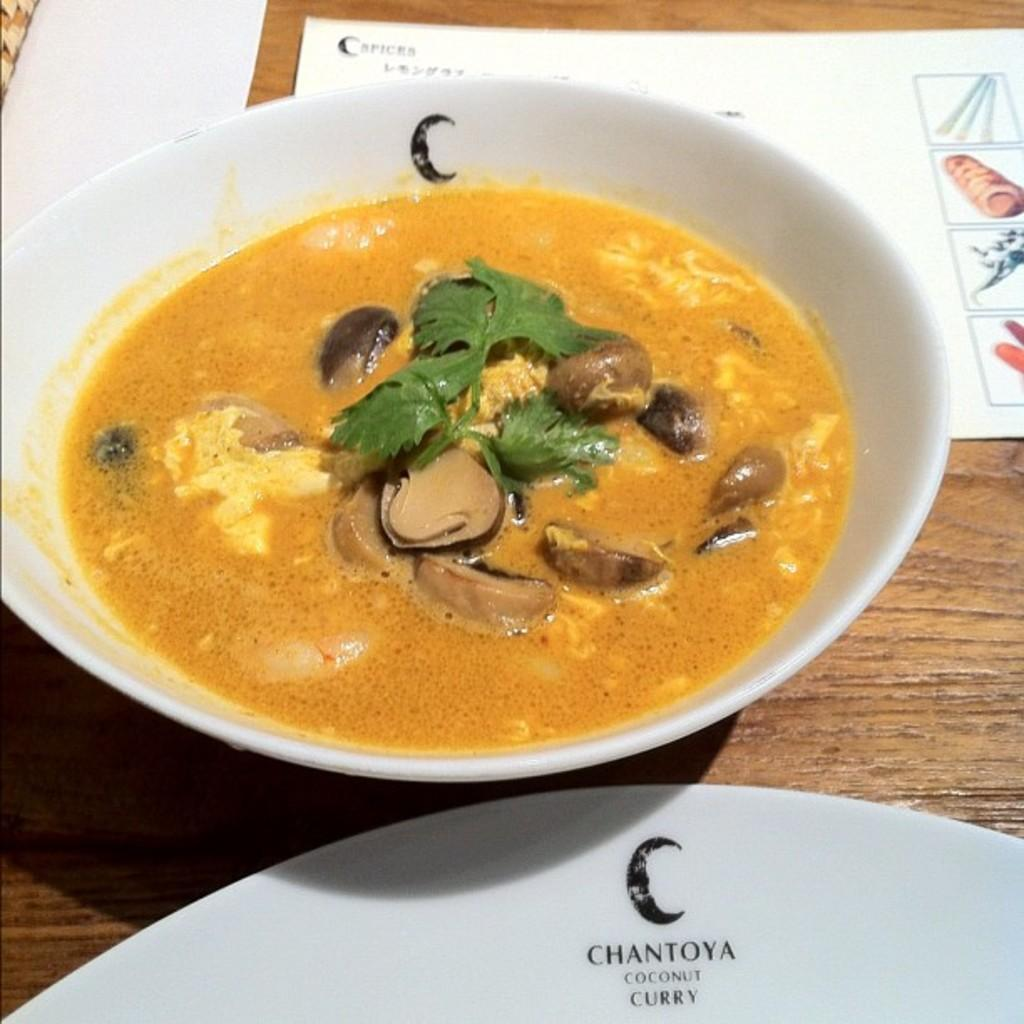What piece of furniture is present in the image? There is a table in the image. What items are placed on the table? There are papers, a plate, and a bowl on the table. What is in the bowl on the table? There is a food item in the bowl. What type of account is being discussed in the image? There is no mention of an account in the image; it features a table with papers, a plate, and a bowl. How many socks are visible in the image? There are no socks present in the image. 